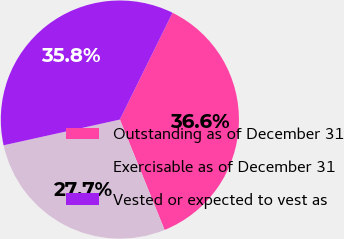<chart> <loc_0><loc_0><loc_500><loc_500><pie_chart><fcel>Outstanding as of December 31<fcel>Exercisable as of December 31<fcel>Vested or expected to vest as<nl><fcel>36.58%<fcel>27.66%<fcel>35.76%<nl></chart> 